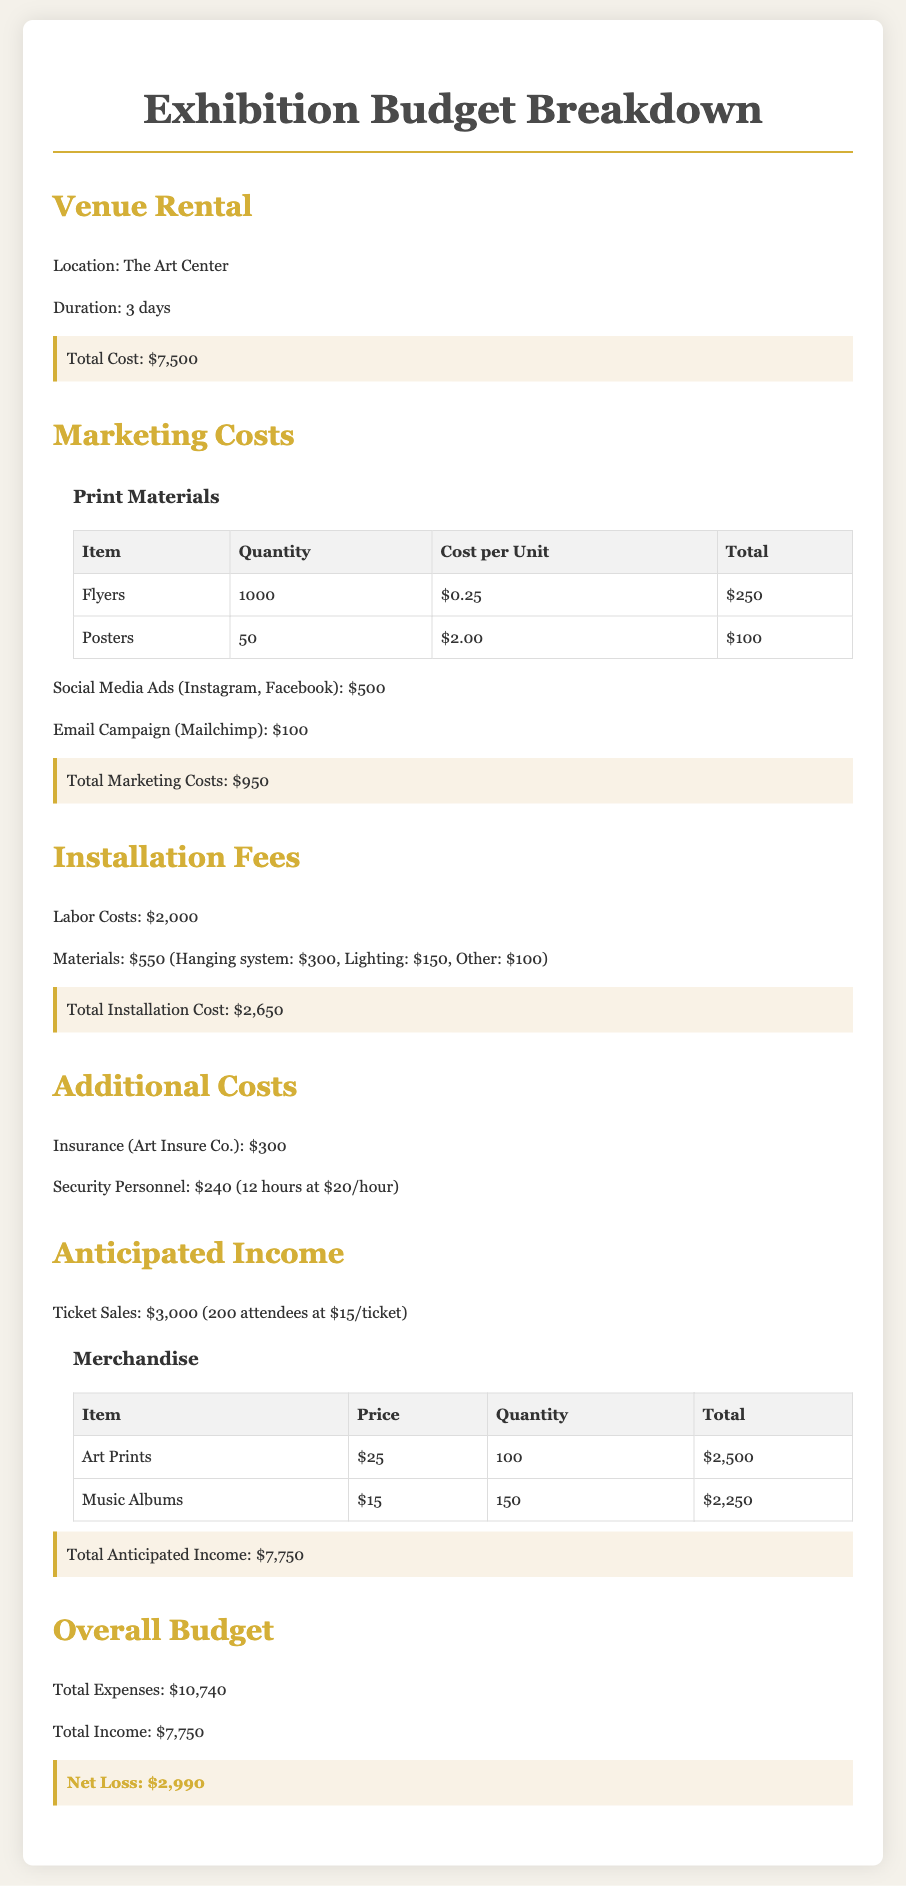What is the total cost of venue rental? The total cost for venue rental is specified in the Venue Rental section of the document.
Answer: $7,500 How many attendees are anticipated for the exhibition? The document states the anticipated number of attendees under Ticket Sales.
Answer: 200 What are the total marketing costs? The total marketing costs are calculated and mentioned at the end of the Marketing Costs section.
Answer: $950 What is the total anticipated income from ticket sales? The total anticipated income from ticket sales is outlined in the Anticipated Income section of the document.
Answer: $3,000 What is the total installation cost? The total installation cost is provided at the end of the Installation Fees section.
Answer: $2,650 What is the total merchandise income? The total income from merchandise is detailed in the Merchandise section under Anticipated Income.
Answer: $4,750 What are the labor costs for installation? The specific amount for labor costs is listed in the Installation Fees section of the document.
Answer: $2,000 What is the net loss calculated for the exhibition? The net loss is summarized in the Overall Budget section, which combines total expenses and income.
Answer: $2,990 